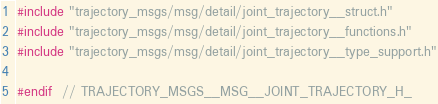Convert code to text. <code><loc_0><loc_0><loc_500><loc_500><_C_>#include "trajectory_msgs/msg/detail/joint_trajectory__struct.h"
#include "trajectory_msgs/msg/detail/joint_trajectory__functions.h"
#include "trajectory_msgs/msg/detail/joint_trajectory__type_support.h"

#endif  // TRAJECTORY_MSGS__MSG__JOINT_TRAJECTORY_H_
</code> 